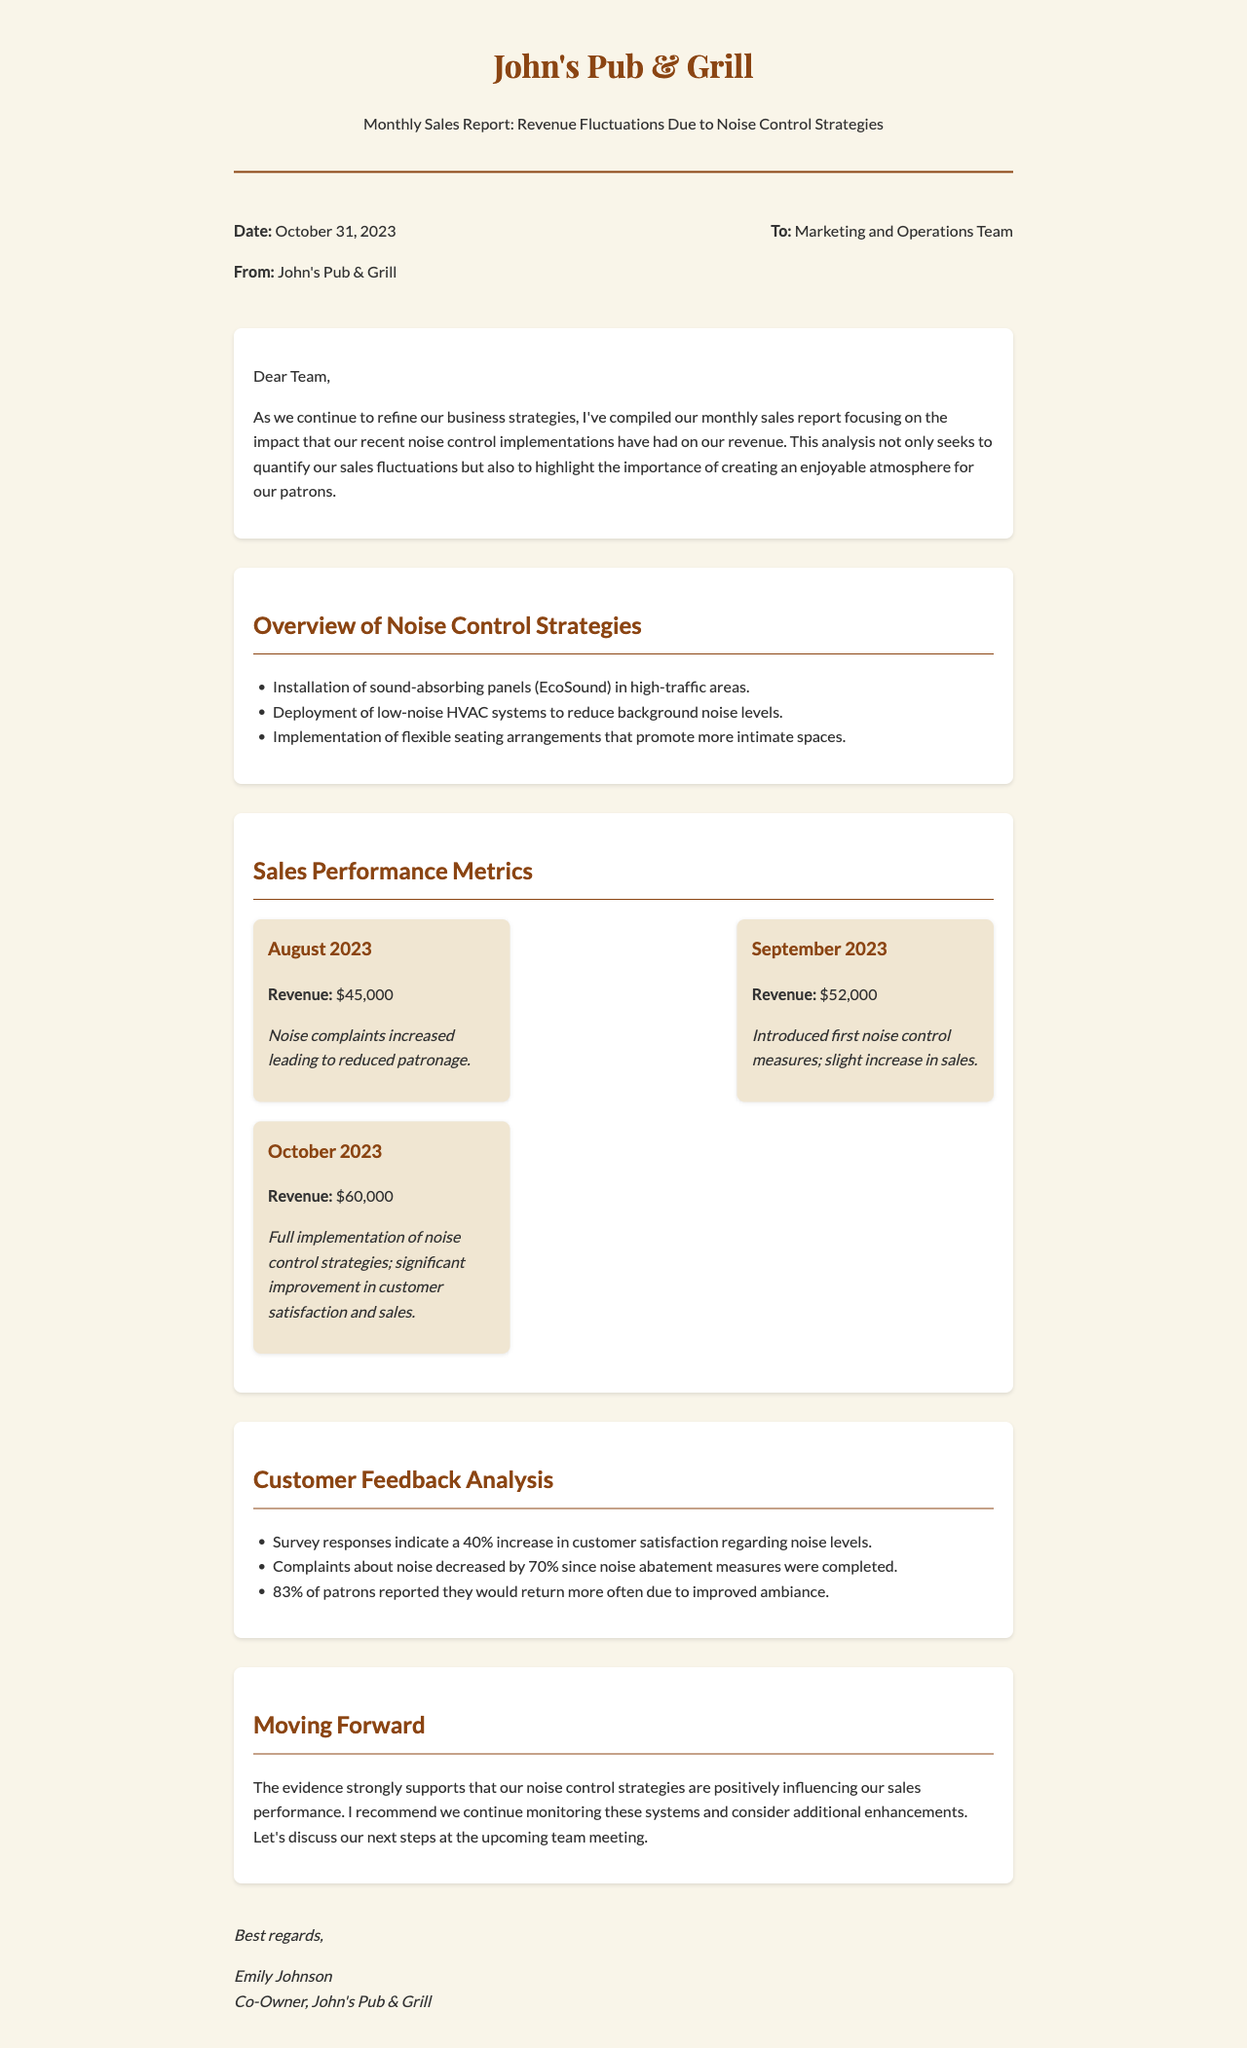What is the date of the report? The report is dated October 31, 2023, as mentioned in the letter meta section.
Answer: October 31, 2023 What was the revenue for September 2023? The revenue for September 2023 is detailed in the sales performance metrics section.
Answer: $52,000 What noise control strategy was implemented first? The first noise control measures were introduced in September 2023, as indicated in the sales metrics.
Answer: First noise control measures How much did customer satisfaction regarding noise levels increase? The document states a 40% increase in customer satisfaction regarding noise levels from the feedback analysis section.
Answer: 40% What percentage of patrons would return more often? The document indicates that 83% of patrons reported they would return more often due to improved ambiance.
Answer: 83% How much did revenue increase from August to October 2023? To find this, subtract August's revenue of $45,000 from October's revenue of $60,000, which shows the revenue increase.
Answer: $15,000 What is the main topic of the letter? The primary focus of the letter is outlined in the title of the report.
Answer: Revenue Fluctuations Due to Noise Control Strategies What is stated about noise complaints from August to October 2023? The letter mentions that complaints about noise decreased by 70% since noise abatement measures were completed, highlighting the effectiveness of the strategies.
Answer: Decreased by 70% What is recommended for the future? The document suggests that further monitoring of the noise control systems and consideration for additional enhancements are desirable moving forward.
Answer: Monitor systems and consider enhancements 